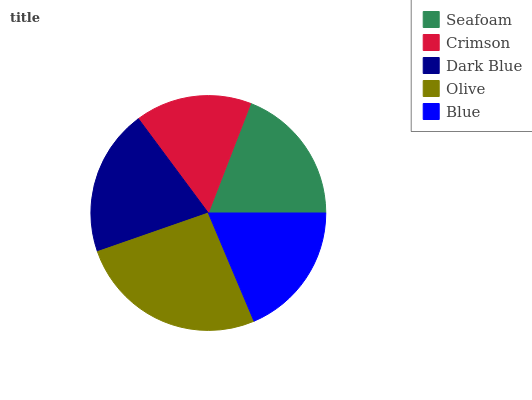Is Crimson the minimum?
Answer yes or no. Yes. Is Olive the maximum?
Answer yes or no. Yes. Is Dark Blue the minimum?
Answer yes or no. No. Is Dark Blue the maximum?
Answer yes or no. No. Is Dark Blue greater than Crimson?
Answer yes or no. Yes. Is Crimson less than Dark Blue?
Answer yes or no. Yes. Is Crimson greater than Dark Blue?
Answer yes or no. No. Is Dark Blue less than Crimson?
Answer yes or no. No. Is Seafoam the high median?
Answer yes or no. Yes. Is Seafoam the low median?
Answer yes or no. Yes. Is Olive the high median?
Answer yes or no. No. Is Olive the low median?
Answer yes or no. No. 